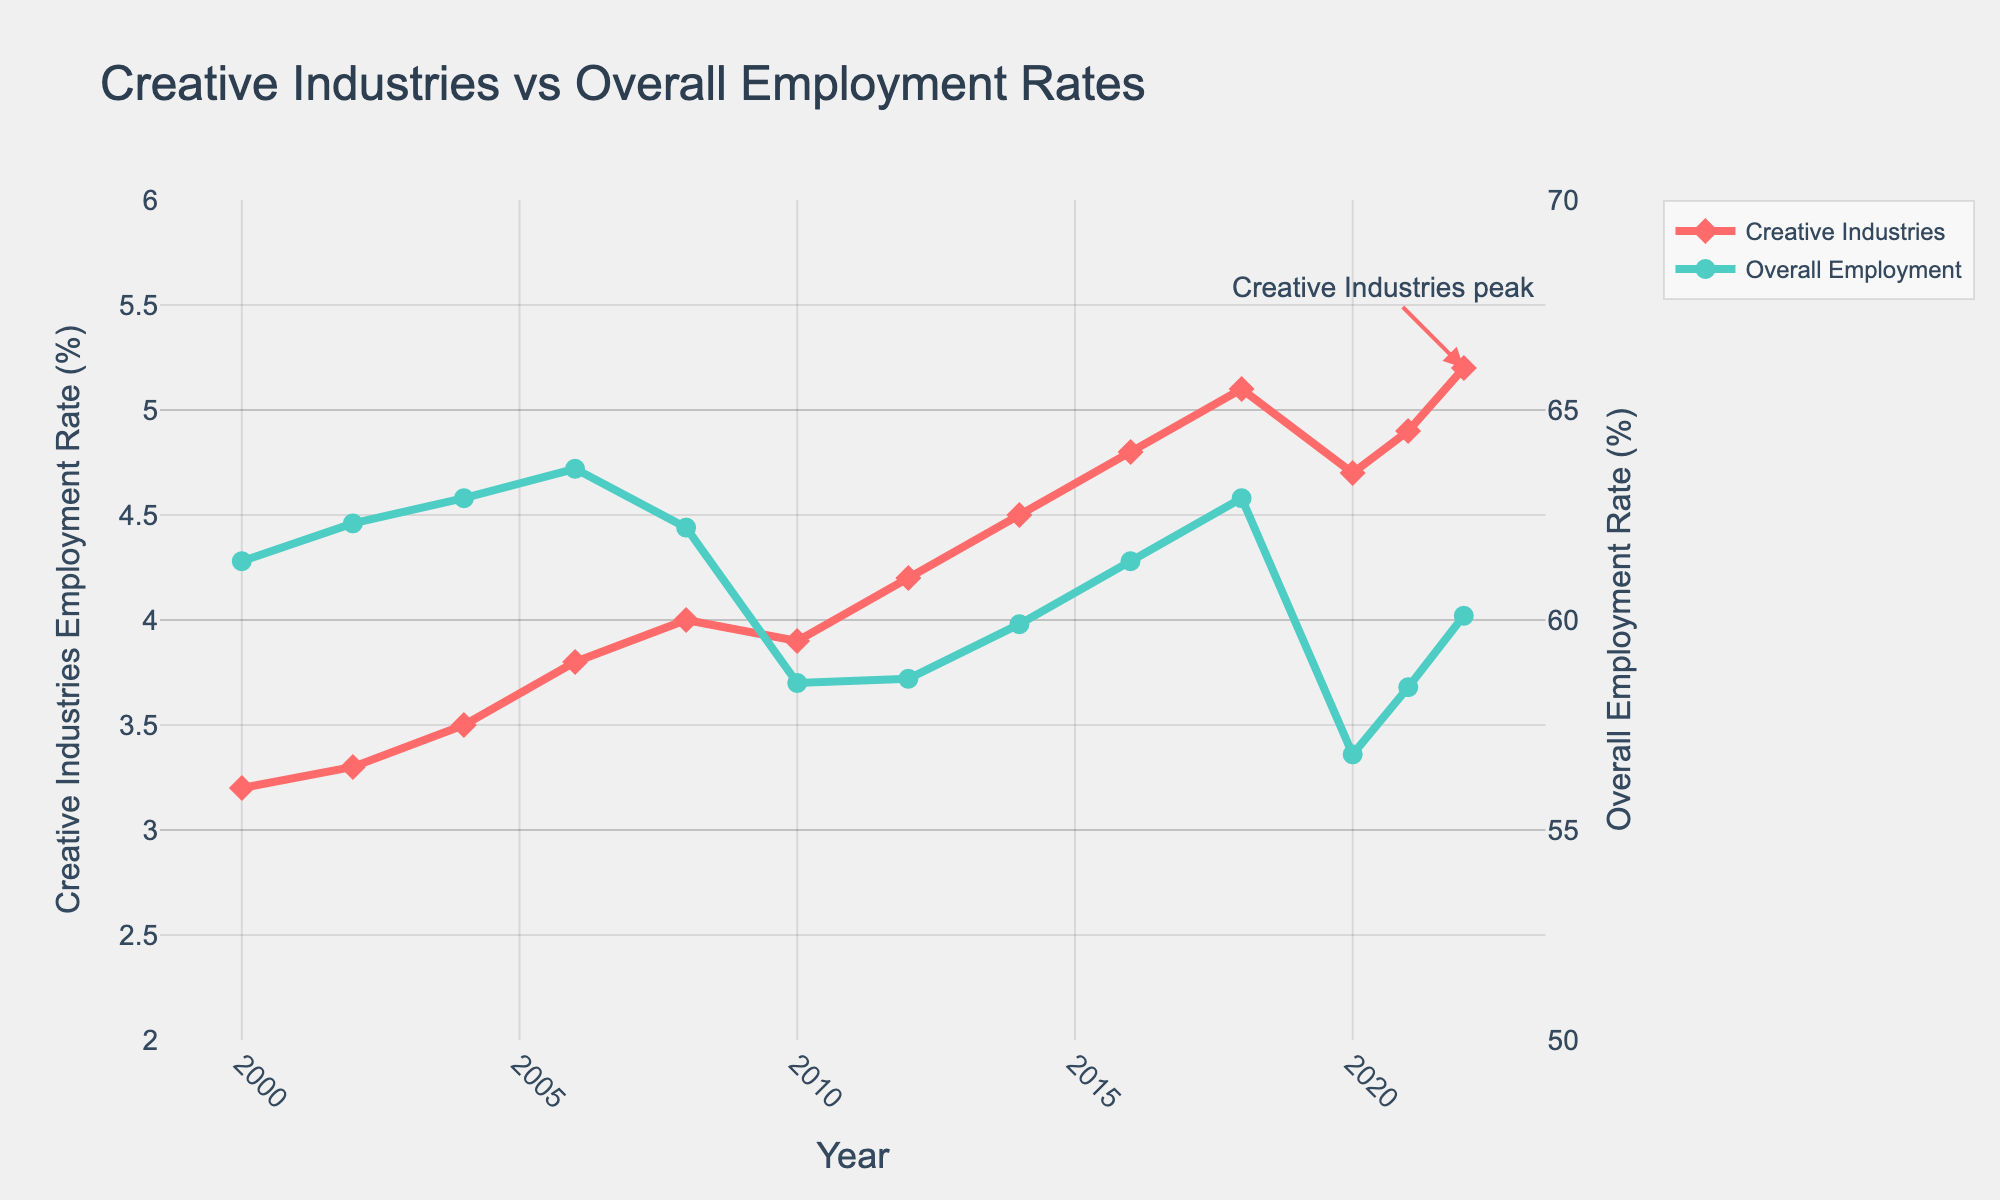What has been the general trend in the employment rate in the creative industries since 2000? The employment rate in the creative industries has shown a general increase from 3.2% in 2000 to 5.2% in 2022. Each subsequent year captures incremental gains, with minor fluctuations around 2010 and 2020.
Answer: Increasing trend How did the employment rate in the creative industries compare to the overall employment rate during the financial crisis around 2008-2010? During the financial crisis, the overall employment rate decreased significantly from 62.2% in 2008 to 58.5% in 2010. In contrast, the employment rate in the creative industries showed a marginal dip from 4.0% in 2008 to 3.9% in 2010.
Answer: Creative industries less impacted Which year marked the highest employment rate in the creative industries? The peak employment rate for the creative industries was in 2022, with a rate of 5.2%. This is noted by the annotation "Creative Industries peak" near the top of the red line.
Answer: 2022 How does the visual representation differentiate between the creative industries' and overall employment rates? The creative industries' employment rate is represented by a red line with diamond markers, while the overall employment rate is shown by a teal line with circle markers. The use of different colors and marker shapes visually distinguishes the two data series.
Answer: Different colors and markers What can you infer about the recovery of overall employment rates post-2008 financial crisis compared to the creative industries? Post-2008, the overall employment took a notable hit, reaching a low in 2010 before a slow recovery. As of 2022, it was 60.1%, still not quite reaching pre-crisis peaks. Conversely, the creative industries not only recovered but showed a significant increase reaching 5.2% in 2022.
Answer: Creative industries recovered better Compare the employment rates of both sectors in 2020. What does this say about the resilience of the creative industries during the COVID-19 pandemic? In 2020, overall employment fell to 56.8%, while the creative industries dipped to 4.7%. Despite the drop, the creative industries sustained a relatively higher employment rate, suggesting comparatively better resilience.
Answer: Creative industries showed better resilience Calculate the average employment rate for the creative industries over the entire period. The average employment rate in the creative industries over the period can be calculated by summing the rates from 2000 to 2022 and then dividing by the number of data points. (3.2 + 3.3 + 3.5 + 3.8 + 4.0 + 3.9 + 4.2 + 4.5 + 4.8 + 5.1 + 4.7 + 4.9 + 5.2) / 13 = 4.25%
Answer: 4.25% Has there been any year where the rate of employment in the creative industries decreased compared to the previous year? Yes, in 2010, the creative industries' employment rate decreased to 3.9% from 4.0% in 2008, and also in 2020, the rate dipped to 4.7% from 5.1% in 2018. These decreases are evident from the downward slopes in the red line.
Answer: 2010 and 2020 What was the difference in the employment rate for the creative industries between 2000 and 2022? The difference in the employment rate between 2000 and 2022 is calculated by subtracting the rate in 2000 from that in 2022. 5.2% - 3.2% = 2%. This shows an overall increase of 2 percentage points over the period.
Answer: 2% What significance do the annotations "Creative Industries peak" and "Pre-financial crisis peak" hold in understanding the trends? These annotations highlight key points in the data. "Creative Industries peak" notes the highest point reached by creative industries in 2022 at 5.2%, while "Pre-financial crisis peak" indicates the high point for overall employment in 2008 at 62.2%, showing significant historical markers.
Answer: Highlight key peaks 